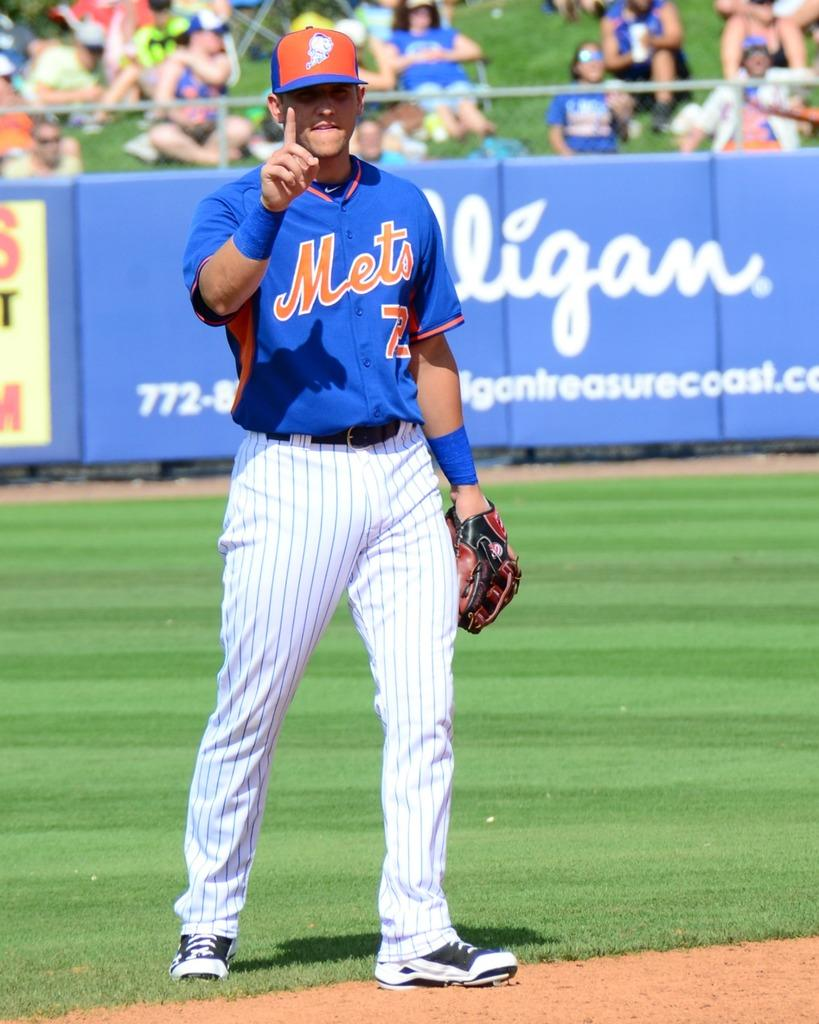<image>
Render a clear and concise summary of the photo. A Mets player on the field with a Culligan banner in the background. 